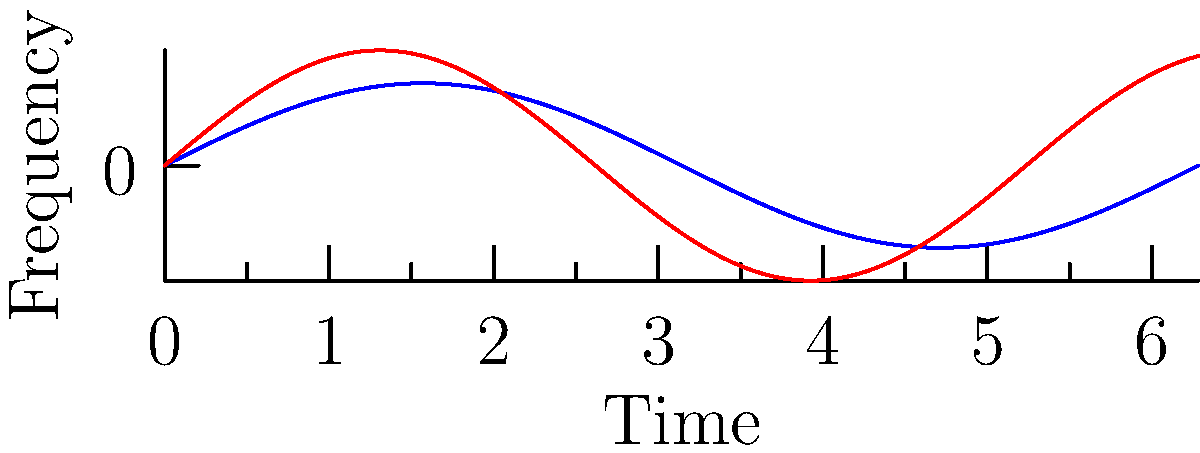The graph shows the frequency variations of spectral lines from two stars, A and B, over time. Based on the Doppler effect, which star is moving away from Earth at a higher velocity? To determine which star is moving away from Earth at a higher velocity using the Doppler effect, we need to analyze the frequency variations:

1. The Doppler effect states that light from objects moving away from us is redshifted (lower frequency), while light from objects moving towards us is blueshifted (higher frequency).

2. For objects moving away, a larger redshift indicates a higher velocity.

3. Comparing the two curves:
   - Star A (blue curve) has a lower amplitude and longer wavelength.
   - Star B (red curve) has a higher amplitude and shorter wavelength.

4. The lower frequency (longer wavelength) of Star A indicates a greater redshift.

5. Therefore, Star A is moving away from Earth at a higher velocity than Star B.
Answer: Star A 